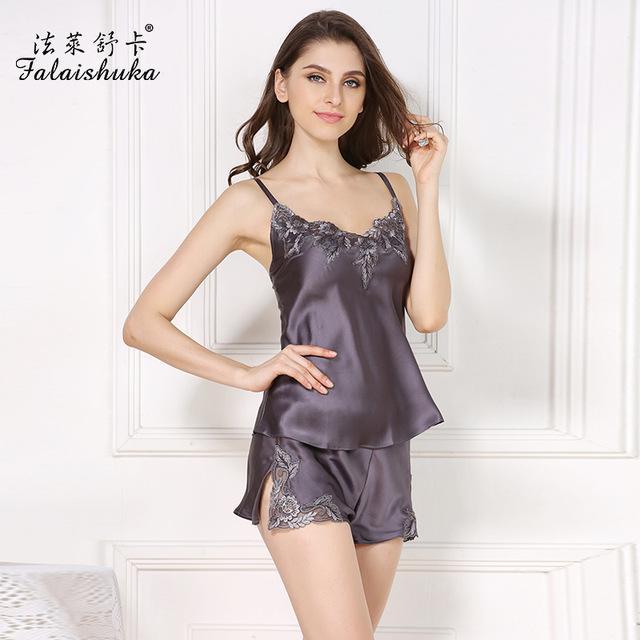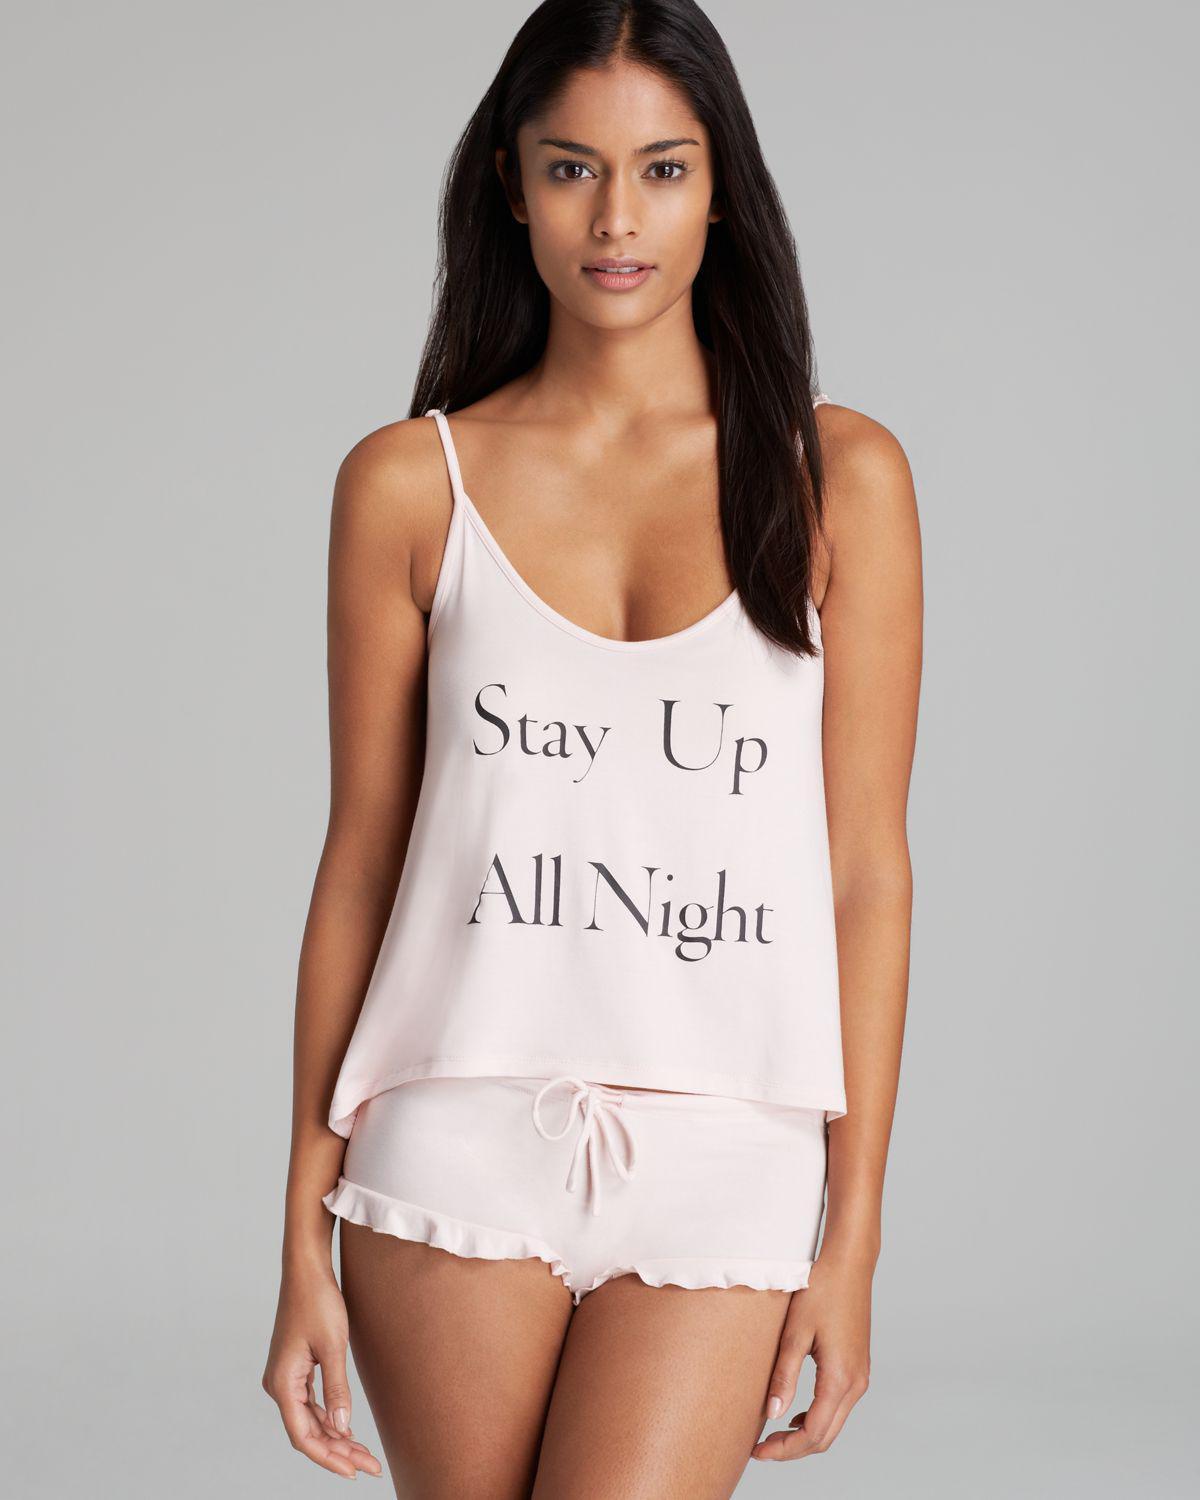The first image is the image on the left, the second image is the image on the right. Considering the images on both sides, is "A woman is wearing a silky shiny pink sleepwear." valid? Answer yes or no. No. 